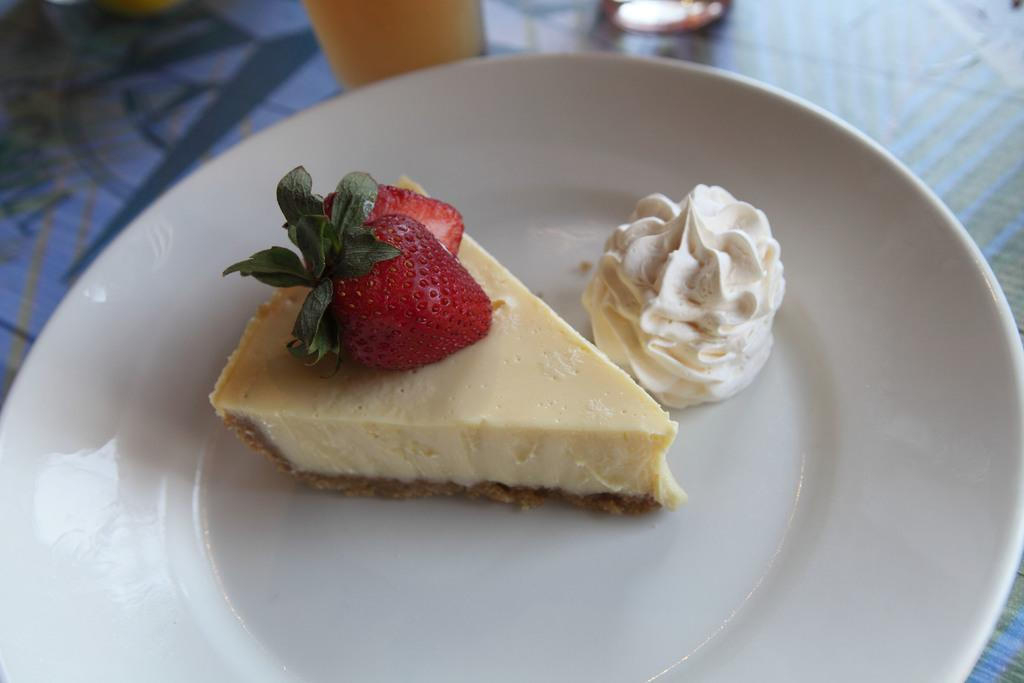What is on the plate that is visible in the image? There are food items on a plate in the image. Where is the plate located in the image? The plate is placed on a table. Can you describe any other objects visible in the image? There is a glass visible in the background of the image. What letters are written on the wrist of the person in the image? There is no person visible in the image, and therefore no wrist or letters written on it. 